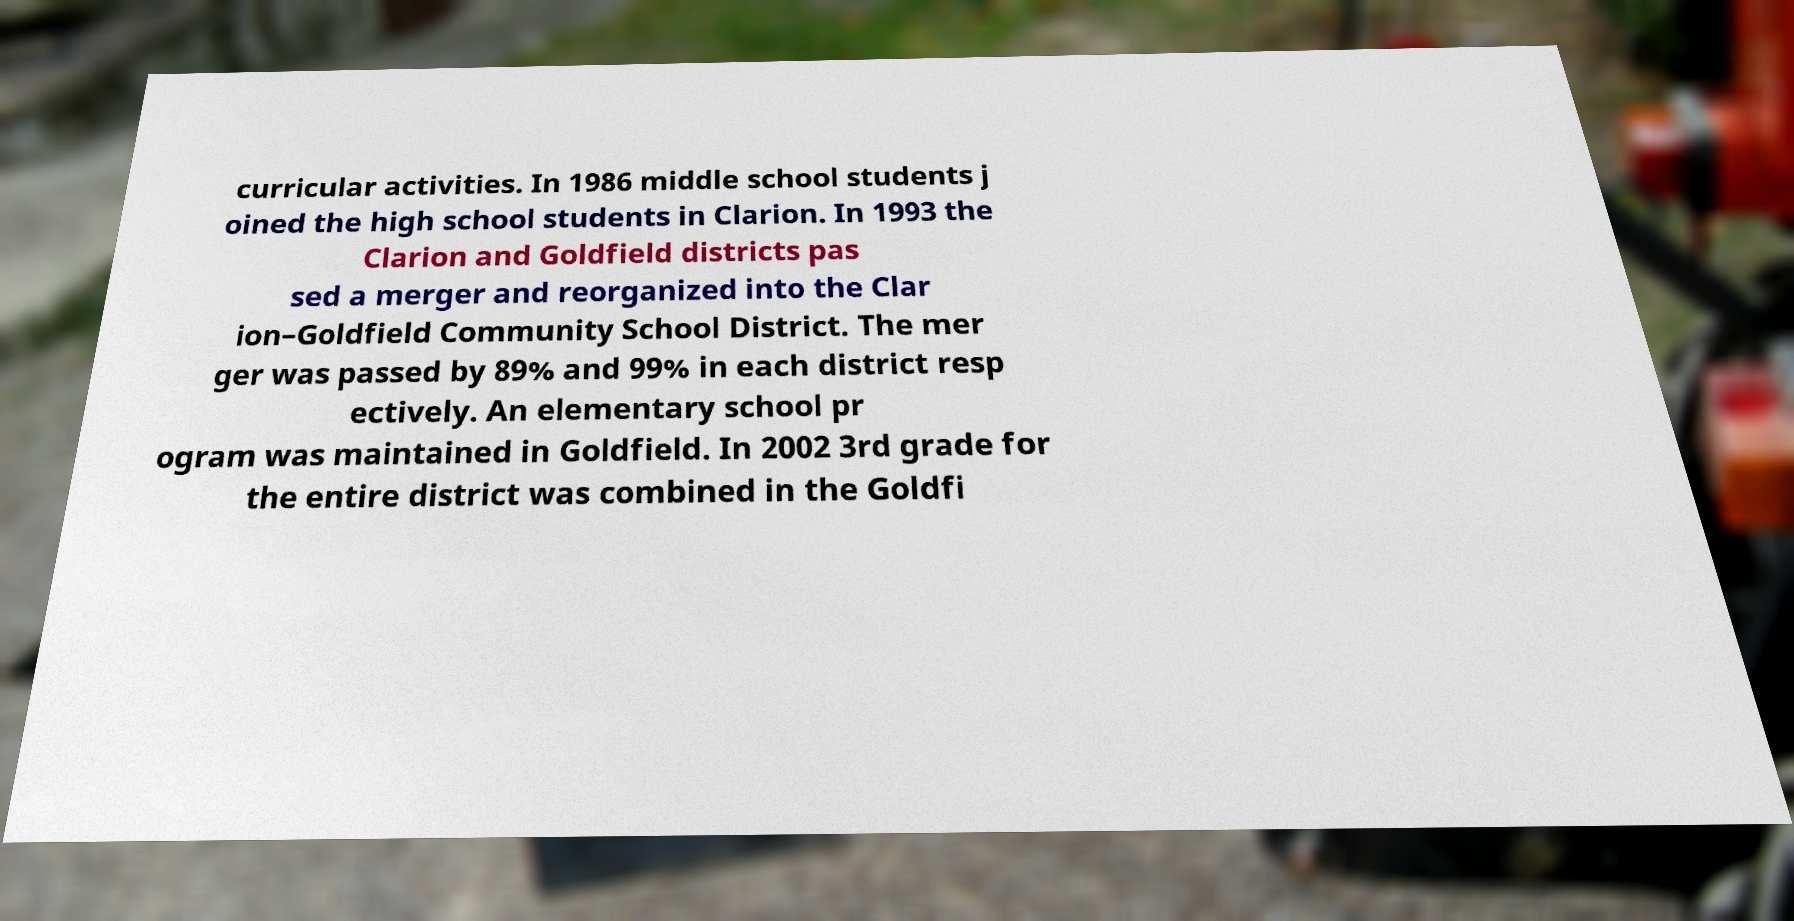Please read and relay the text visible in this image. What does it say? curricular activities. In 1986 middle school students j oined the high school students in Clarion. In 1993 the Clarion and Goldfield districts pas sed a merger and reorganized into the Clar ion–Goldfield Community School District. The mer ger was passed by 89% and 99% in each district resp ectively. An elementary school pr ogram was maintained in Goldfield. In 2002 3rd grade for the entire district was combined in the Goldfi 